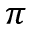Convert formula to latex. <formula><loc_0><loc_0><loc_500><loc_500>\pi</formula> 